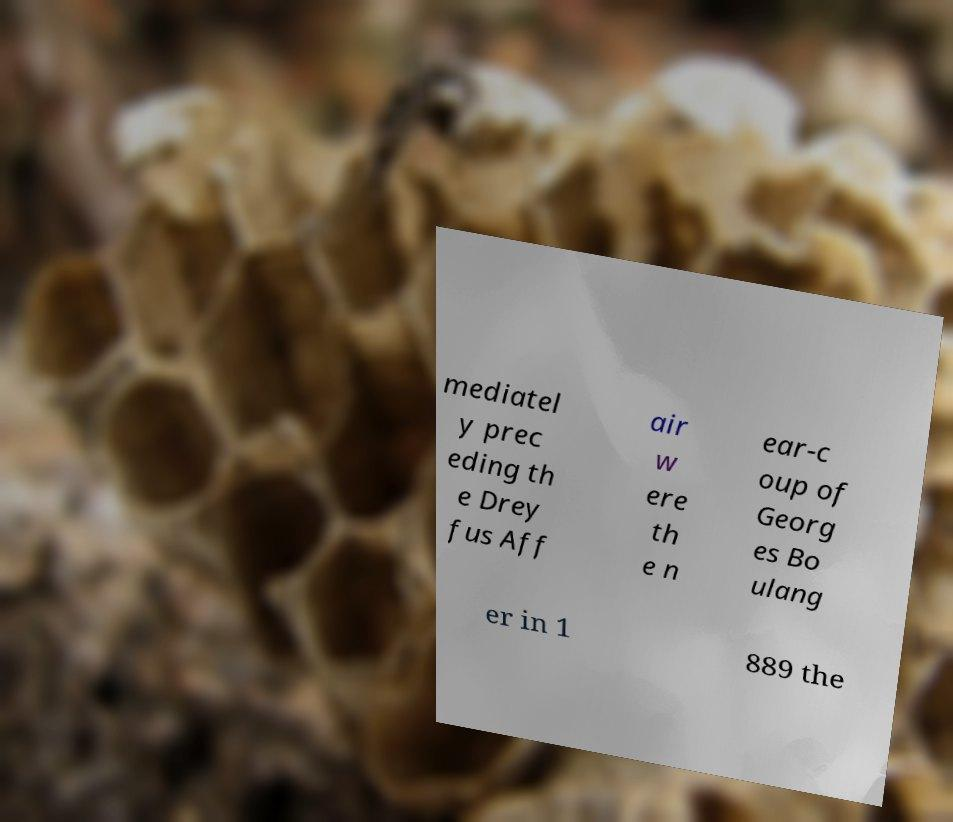Please identify and transcribe the text found in this image. mediatel y prec eding th e Drey fus Aff air w ere th e n ear-c oup of Georg es Bo ulang er in 1 889 the 